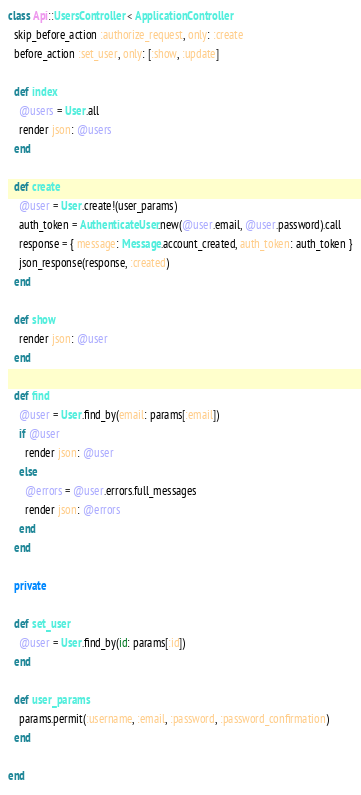<code> <loc_0><loc_0><loc_500><loc_500><_Ruby_>class Api::UsersController < ApplicationController
  skip_before_action :authorize_request, only: :create
  before_action :set_user, only: [:show, :update]

  def index
    @users = User.all
    render json: @users
  end

  def create
    @user = User.create!(user_params)
    auth_token = AuthenticateUser.new(@user.email, @user.password).call
    response = { message: Message.account_created, auth_token: auth_token }
    json_response(response, :created)
  end

  def show
    render json: @user
  end

  def find
    @user = User.find_by(email: params[:email])
    if @user
      render json: @user
    else
      @errors = @user.errors.full_messages
      render json: @errors
    end
  end

  private

  def set_user
    @user = User.find_by(id: params[:id])
  end

  def user_params
    params.permit(:username, :email, :password, :password_confirmation)
  end

end
</code> 